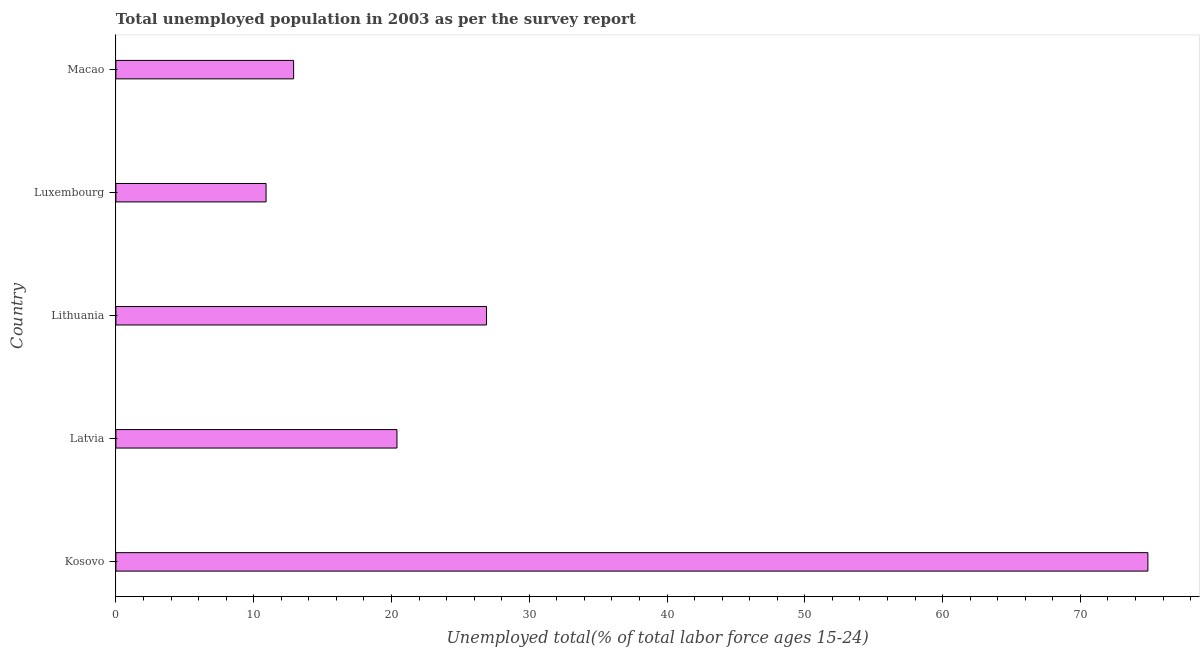Does the graph contain any zero values?
Your response must be concise. No. Does the graph contain grids?
Ensure brevity in your answer.  No. What is the title of the graph?
Offer a very short reply. Total unemployed population in 2003 as per the survey report. What is the label or title of the X-axis?
Your response must be concise. Unemployed total(% of total labor force ages 15-24). What is the label or title of the Y-axis?
Ensure brevity in your answer.  Country. What is the unemployed youth in Latvia?
Your response must be concise. 20.4. Across all countries, what is the maximum unemployed youth?
Give a very brief answer. 74.9. Across all countries, what is the minimum unemployed youth?
Ensure brevity in your answer.  10.9. In which country was the unemployed youth maximum?
Provide a short and direct response. Kosovo. In which country was the unemployed youth minimum?
Ensure brevity in your answer.  Luxembourg. What is the sum of the unemployed youth?
Give a very brief answer. 146. What is the average unemployed youth per country?
Offer a terse response. 29.2. What is the median unemployed youth?
Offer a terse response. 20.4. In how many countries, is the unemployed youth greater than 44 %?
Offer a terse response. 1. What is the ratio of the unemployed youth in Kosovo to that in Macao?
Keep it short and to the point. 5.81. Is the difference between the unemployed youth in Latvia and Macao greater than the difference between any two countries?
Offer a very short reply. No. What is the difference between the highest and the second highest unemployed youth?
Your response must be concise. 48. What is the difference between the highest and the lowest unemployed youth?
Ensure brevity in your answer.  64. In how many countries, is the unemployed youth greater than the average unemployed youth taken over all countries?
Offer a very short reply. 1. How many bars are there?
Your answer should be very brief. 5. Are all the bars in the graph horizontal?
Ensure brevity in your answer.  Yes. What is the Unemployed total(% of total labor force ages 15-24) in Kosovo?
Offer a very short reply. 74.9. What is the Unemployed total(% of total labor force ages 15-24) in Latvia?
Offer a terse response. 20.4. What is the Unemployed total(% of total labor force ages 15-24) of Lithuania?
Offer a terse response. 26.9. What is the Unemployed total(% of total labor force ages 15-24) of Luxembourg?
Provide a succinct answer. 10.9. What is the Unemployed total(% of total labor force ages 15-24) of Macao?
Provide a succinct answer. 12.9. What is the difference between the Unemployed total(% of total labor force ages 15-24) in Kosovo and Latvia?
Your response must be concise. 54.5. What is the difference between the Unemployed total(% of total labor force ages 15-24) in Kosovo and Lithuania?
Ensure brevity in your answer.  48. What is the difference between the Unemployed total(% of total labor force ages 15-24) in Kosovo and Luxembourg?
Offer a very short reply. 64. What is the difference between the Unemployed total(% of total labor force ages 15-24) in Latvia and Lithuania?
Your answer should be compact. -6.5. What is the difference between the Unemployed total(% of total labor force ages 15-24) in Latvia and Luxembourg?
Provide a short and direct response. 9.5. What is the difference between the Unemployed total(% of total labor force ages 15-24) in Latvia and Macao?
Your answer should be compact. 7.5. What is the difference between the Unemployed total(% of total labor force ages 15-24) in Luxembourg and Macao?
Your response must be concise. -2. What is the ratio of the Unemployed total(% of total labor force ages 15-24) in Kosovo to that in Latvia?
Give a very brief answer. 3.67. What is the ratio of the Unemployed total(% of total labor force ages 15-24) in Kosovo to that in Lithuania?
Ensure brevity in your answer.  2.78. What is the ratio of the Unemployed total(% of total labor force ages 15-24) in Kosovo to that in Luxembourg?
Your response must be concise. 6.87. What is the ratio of the Unemployed total(% of total labor force ages 15-24) in Kosovo to that in Macao?
Provide a short and direct response. 5.81. What is the ratio of the Unemployed total(% of total labor force ages 15-24) in Latvia to that in Lithuania?
Offer a very short reply. 0.76. What is the ratio of the Unemployed total(% of total labor force ages 15-24) in Latvia to that in Luxembourg?
Provide a short and direct response. 1.87. What is the ratio of the Unemployed total(% of total labor force ages 15-24) in Latvia to that in Macao?
Make the answer very short. 1.58. What is the ratio of the Unemployed total(% of total labor force ages 15-24) in Lithuania to that in Luxembourg?
Your response must be concise. 2.47. What is the ratio of the Unemployed total(% of total labor force ages 15-24) in Lithuania to that in Macao?
Offer a very short reply. 2.08. What is the ratio of the Unemployed total(% of total labor force ages 15-24) in Luxembourg to that in Macao?
Your answer should be very brief. 0.84. 